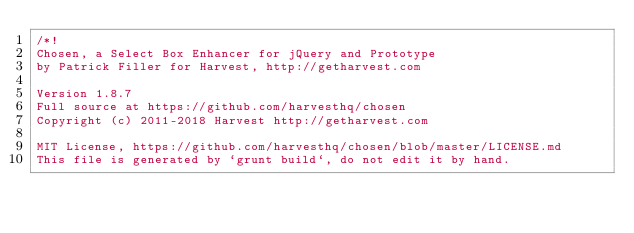<code> <loc_0><loc_0><loc_500><loc_500><_CSS_>/*!
Chosen, a Select Box Enhancer for jQuery and Prototype
by Patrick Filler for Harvest, http://getharvest.com

Version 1.8.7
Full source at https://github.com/harvesthq/chosen
Copyright (c) 2011-2018 Harvest http://getharvest.com

MIT License, https://github.com/harvesthq/chosen/blob/master/LICENSE.md
This file is generated by `grunt build`, do not edit it by hand.</code> 